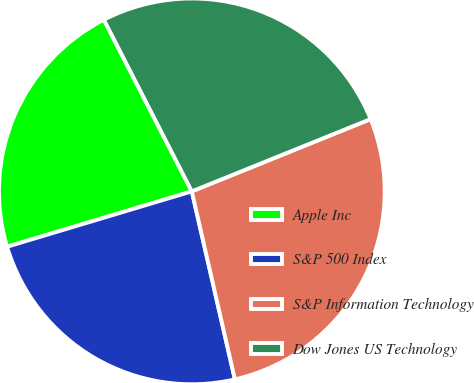<chart> <loc_0><loc_0><loc_500><loc_500><pie_chart><fcel>Apple Inc<fcel>S&P 500 Index<fcel>S&P Information Technology<fcel>Dow Jones US Technology<nl><fcel>22.1%<fcel>23.95%<fcel>27.53%<fcel>26.42%<nl></chart> 